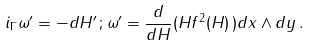Convert formula to latex. <formula><loc_0><loc_0><loc_500><loc_500>i _ { \Gamma } \omega ^ { \prime } = - d H ^ { \prime } \, ; \omega ^ { \prime } = \frac { d } { d H } ( H f ^ { 2 } ( H ) \, ) d x \wedge d y \, .</formula> 